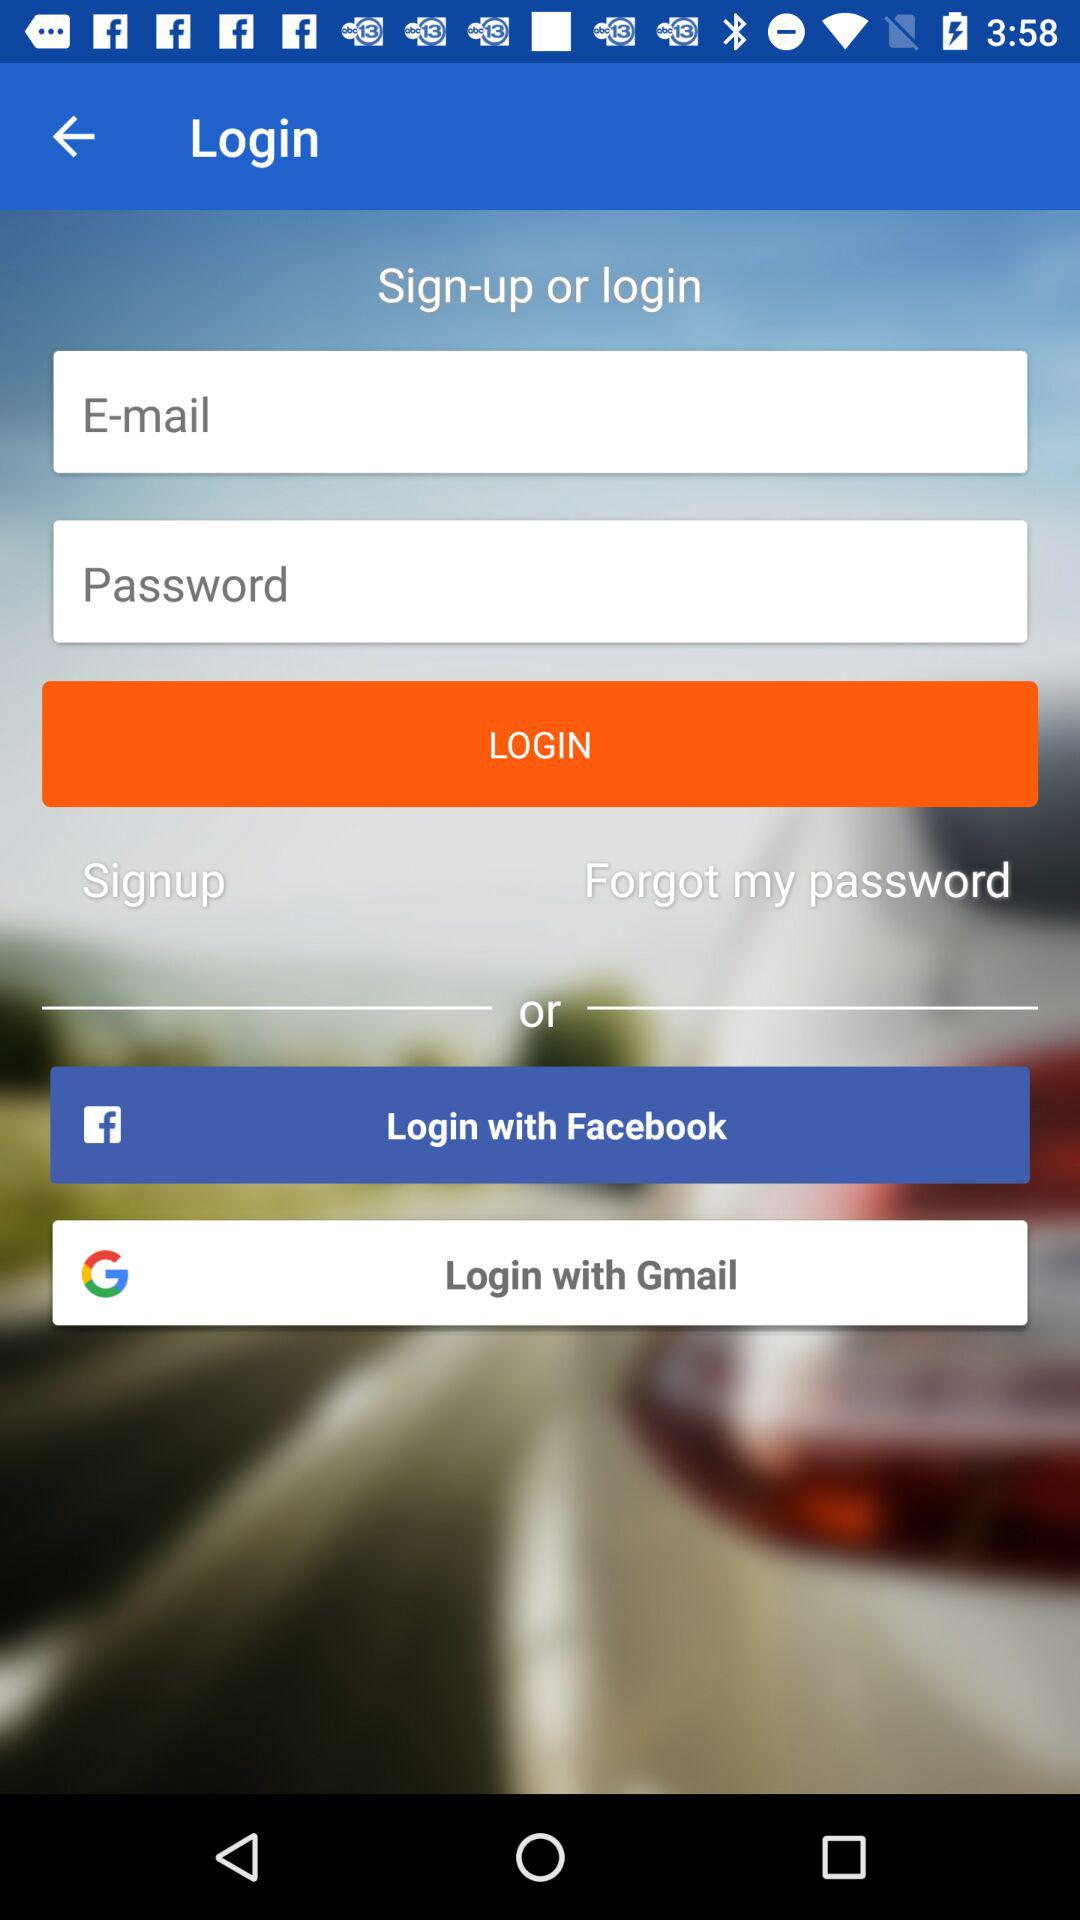What are the different applications through which we can login? The different applications are: "E-mail", "Login with Facebook", and "Login with Gmail". 